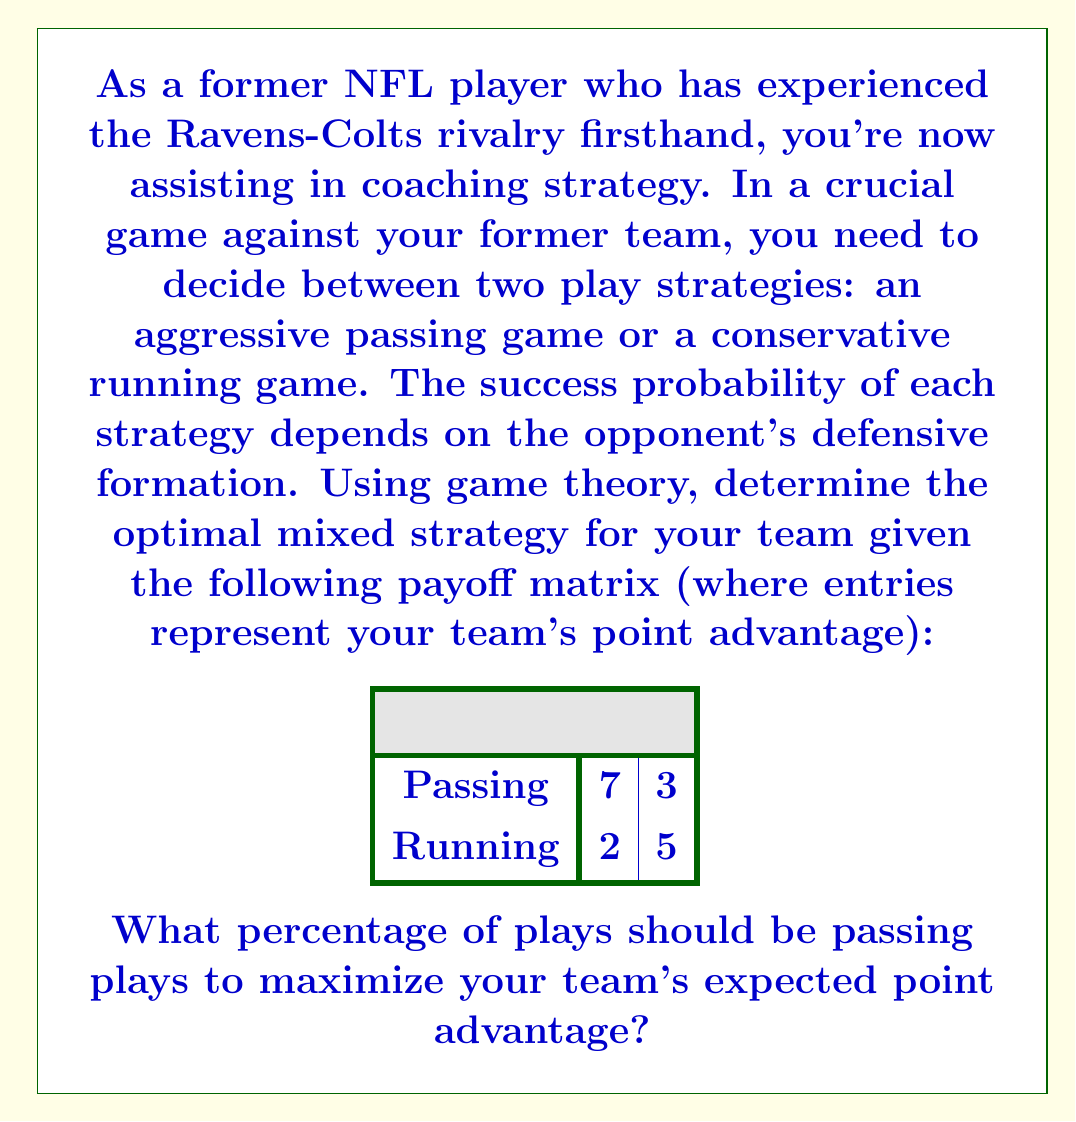Solve this math problem. To solve this problem, we'll use the concept of mixed strategy Nash equilibrium from game theory. Here's the step-by-step solution:

1) Let $p$ be the probability of choosing the passing strategy, and $(1-p)$ the probability of choosing the running strategy.

2) Let $q$ be the probability of the opponent choosing to blitz, and $(1-q)$ the probability of choosing coverage.

3) The expected payoff for passing is:
   $E(\text{Pass}) = 7q + 3(1-q) = 4q + 3$

4) The expected payoff for running is:
   $E(\text{Run}) = 2q + 5(1-q) = 5 - 3q$

5) In a mixed strategy equilibrium, these expected payoffs should be equal:
   $4q + 3 = 5 - 3q$

6) Solve this equation:
   $4q + 3 = 5 - 3q$
   $7q = 2$
   $q = \frac{2}{7}$

7) Now, for the opponent to be indifferent between their strategies, we need:
   $7p + 2(1-p) = 3p + 5(1-p)$

8) Solve this equation:
   $7p + 2 - 2p = 3p + 5 - 5p$
   $5p + 2 = -2p + 5$
   $7p = 3$
   $p = \frac{3}{7}$

Therefore, the optimal strategy is to choose passing plays $\frac{3}{7}$ of the time, which is approximately 42.86% of the plays.
Answer: $\frac{3}{7}$ or approximately 42.86% 